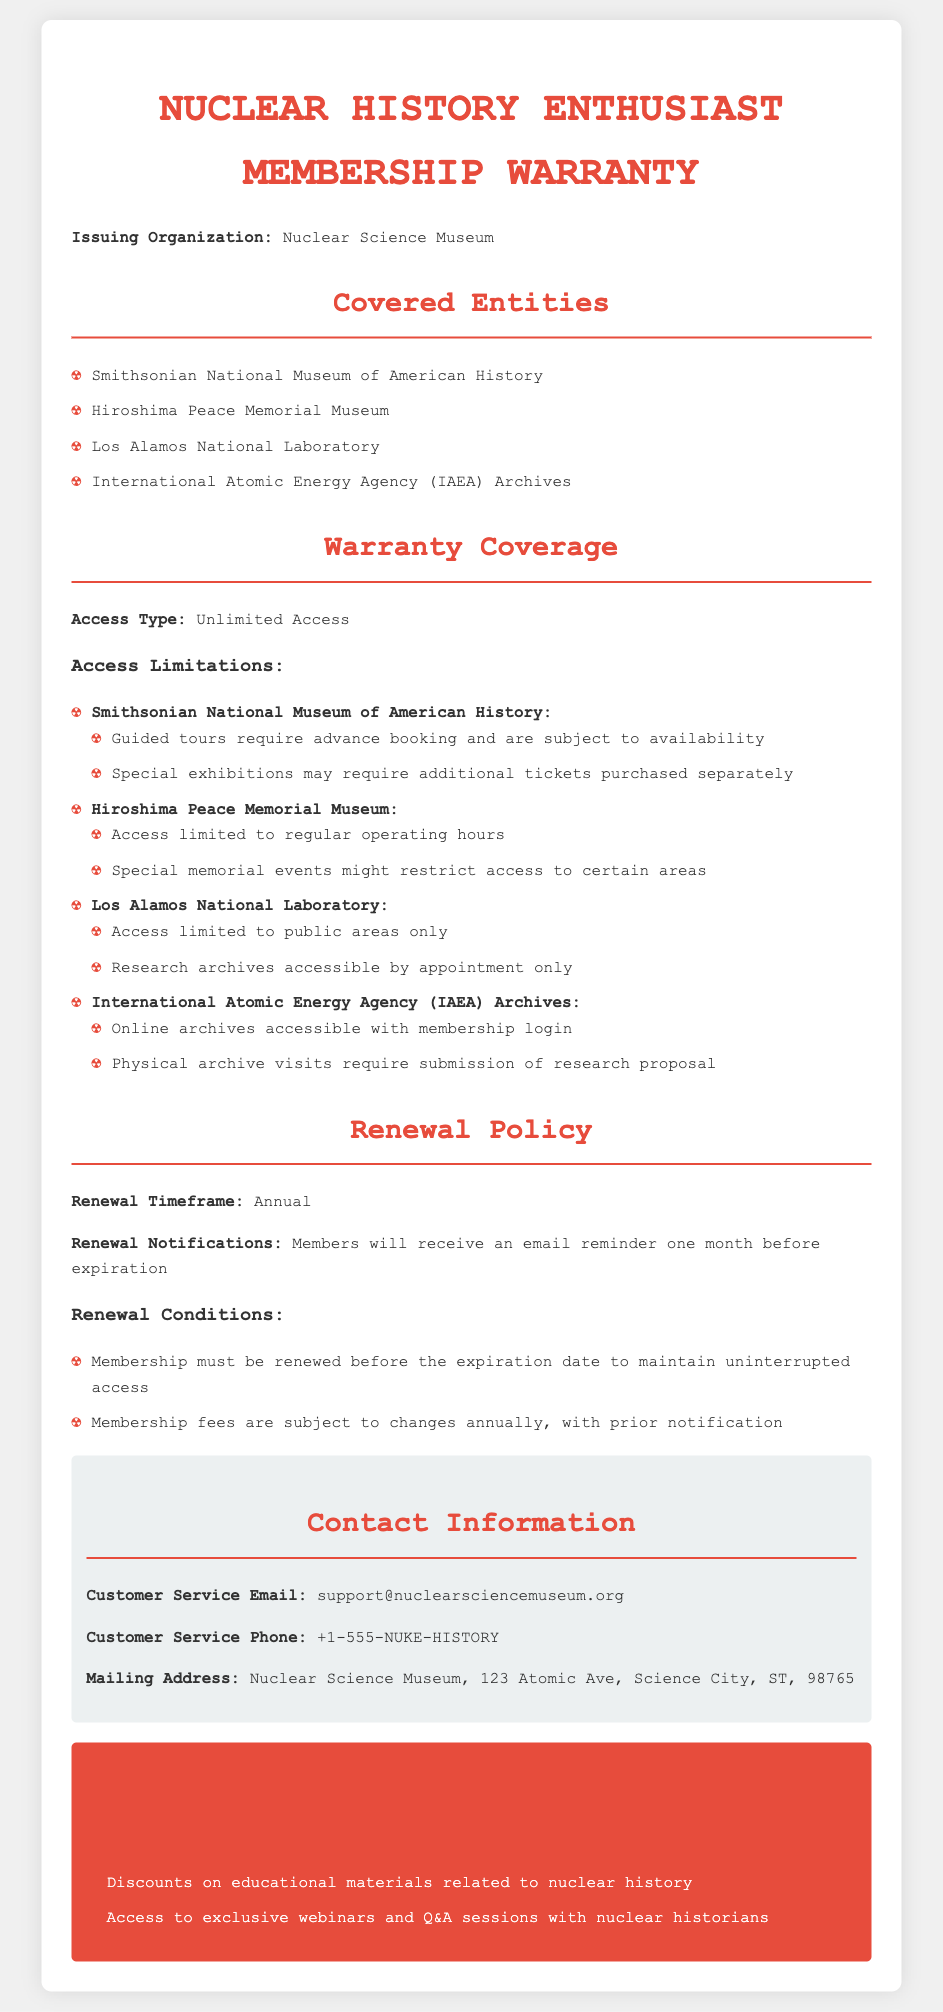what is the issuing organization? The document specifies the issuing organization is the Nuclear Science Museum.
Answer: Nuclear Science Museum how often must the membership be renewed? The document states that the membership must be renewed annually.
Answer: Annual what are the operating hours for the Hiroshima Peace Memorial Museum? The document mentions that access is limited to regular operating hours.
Answer: Regular operating hours what are the additional benefits of the membership? The document lists discounts on educational materials and access to exclusive webinars as additional benefits.
Answer: Discounts on educational materials and access to exclusive webinars which museum requires submission of a research proposal for archive visits? The document indicates that visits to the International Atomic Energy Agency Archives require submission of a research proposal.
Answer: International Atomic Energy Agency Archives how will members be notified of renewal? According to the document, members will receive an email reminder one month before expiration.
Answer: Email reminder what is the contact email for customer service? The document provides the customer service email as support@nuclearsciencemuseum.org.
Answer: support@nuclearsciencemuseum.org what is required for access to the Los Alamos National Laboratory archives? The document states that access to the research archives is by appointment only.
Answer: Appointment only 